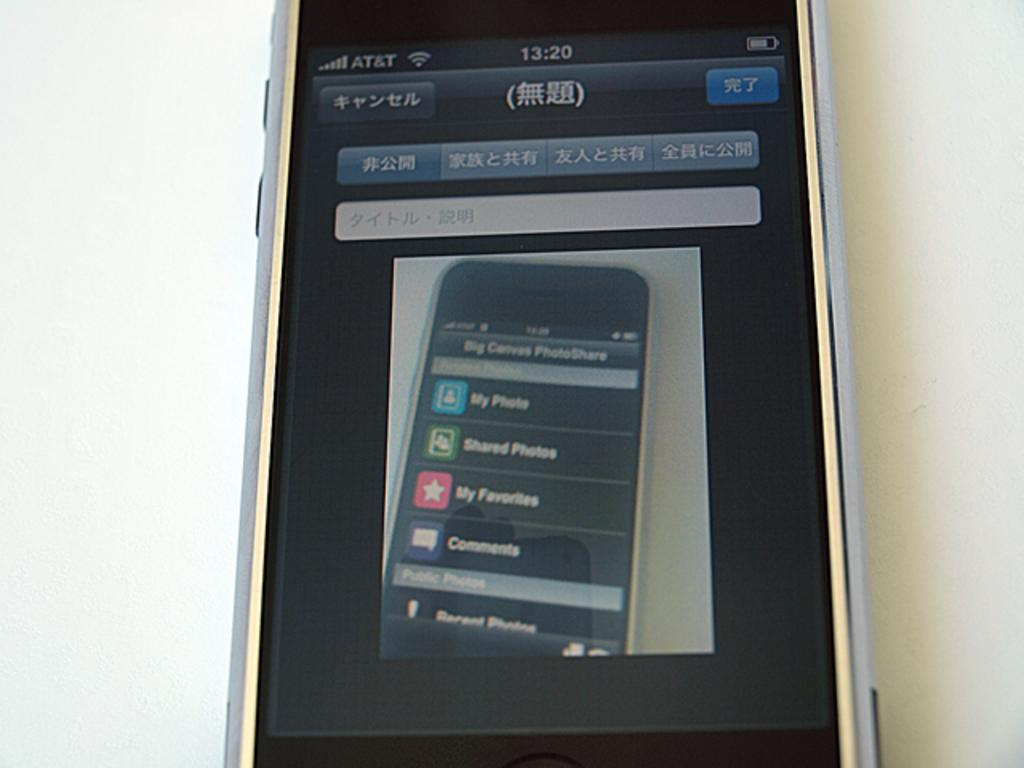Provide a one-sentence caption for the provided image. An iPhone with the Photoshare screen open showing my photo, shared photos and my favorites. 